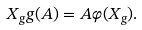<formula> <loc_0><loc_0><loc_500><loc_500>X _ { g } g ( A ) = A \varphi ( X _ { g } ) .</formula> 